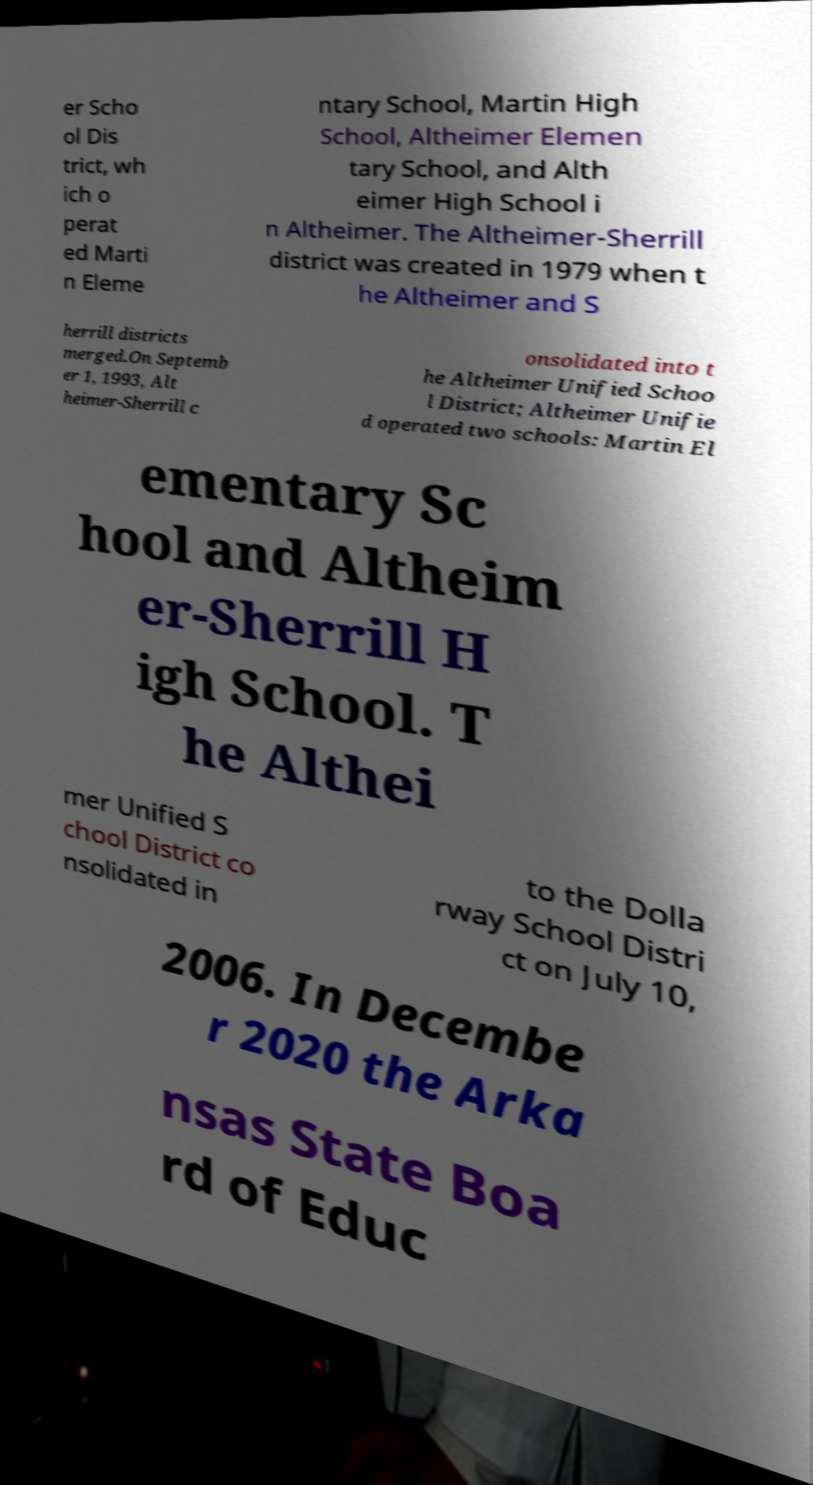Please read and relay the text visible in this image. What does it say? er Scho ol Dis trict, wh ich o perat ed Marti n Eleme ntary School, Martin High School, Altheimer Elemen tary School, and Alth eimer High School i n Altheimer. The Altheimer-Sherrill district was created in 1979 when t he Altheimer and S herrill districts merged.On Septemb er 1, 1993, Alt heimer-Sherrill c onsolidated into t he Altheimer Unified Schoo l District; Altheimer Unifie d operated two schools: Martin El ementary Sc hool and Altheim er-Sherrill H igh School. T he Althei mer Unified S chool District co nsolidated in to the Dolla rway School Distri ct on July 10, 2006. In Decembe r 2020 the Arka nsas State Boa rd of Educ 